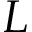<formula> <loc_0><loc_0><loc_500><loc_500>L</formula> 